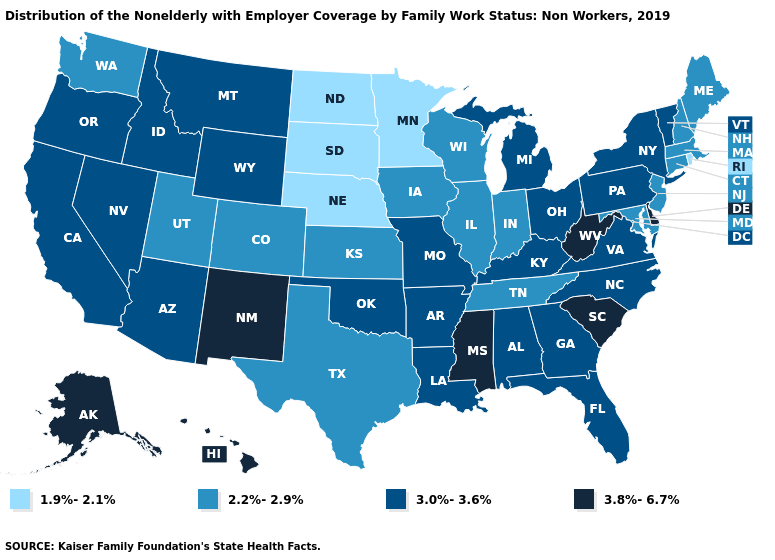What is the value of Louisiana?
Keep it brief. 3.0%-3.6%. What is the lowest value in states that border Nevada?
Give a very brief answer. 2.2%-2.9%. What is the highest value in the USA?
Short answer required. 3.8%-6.7%. What is the highest value in the USA?
Give a very brief answer. 3.8%-6.7%. Does New Hampshire have a higher value than Kentucky?
Give a very brief answer. No. Name the states that have a value in the range 3.8%-6.7%?
Be succinct. Alaska, Delaware, Hawaii, Mississippi, New Mexico, South Carolina, West Virginia. Does Wyoming have the same value as Massachusetts?
Write a very short answer. No. What is the value of North Dakota?
Quick response, please. 1.9%-2.1%. What is the value of New Mexico?
Answer briefly. 3.8%-6.7%. Among the states that border Virginia , does Tennessee have the lowest value?
Give a very brief answer. Yes. What is the value of Mississippi?
Be succinct. 3.8%-6.7%. Does Hawaii have the highest value in the USA?
Be succinct. Yes. Which states have the lowest value in the USA?
Concise answer only. Minnesota, Nebraska, North Dakota, Rhode Island, South Dakota. What is the highest value in states that border Idaho?
Keep it brief. 3.0%-3.6%. 